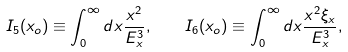<formula> <loc_0><loc_0><loc_500><loc_500>I _ { 5 } ( x _ { o } ) \equiv \int _ { 0 } ^ { \infty } d x \frac { x ^ { 2 } } { E _ { x } ^ { 3 } } , \quad I _ { 6 } ( x _ { o } ) \equiv \int _ { 0 } ^ { \infty } d x \frac { x ^ { 2 } \xi _ { x } } { E _ { x } ^ { 3 } } ,</formula> 